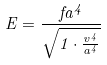<formula> <loc_0><loc_0><loc_500><loc_500>E = \frac { f a ^ { 4 } } { \sqrt { 1 \cdot \frac { v ^ { 4 } } { a ^ { 4 } } } }</formula> 